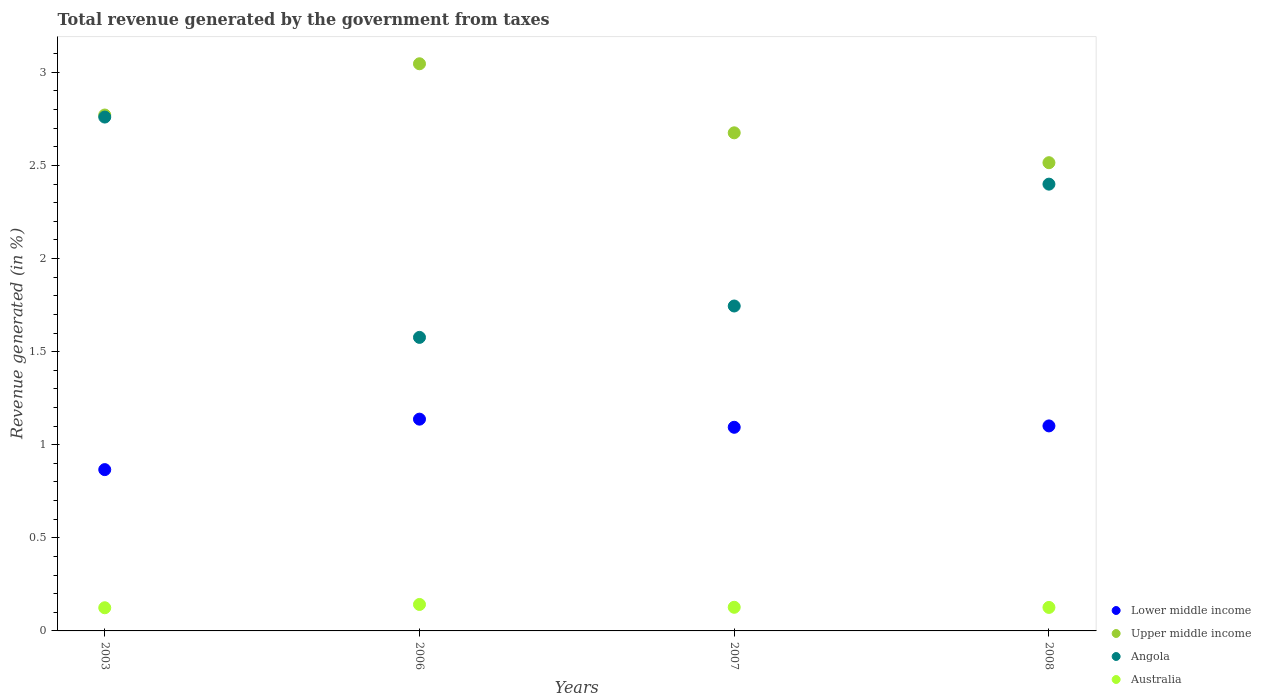How many different coloured dotlines are there?
Give a very brief answer. 4. What is the total revenue generated in Upper middle income in 2003?
Make the answer very short. 2.77. Across all years, what is the maximum total revenue generated in Lower middle income?
Your response must be concise. 1.14. Across all years, what is the minimum total revenue generated in Australia?
Offer a very short reply. 0.12. What is the total total revenue generated in Australia in the graph?
Ensure brevity in your answer.  0.52. What is the difference between the total revenue generated in Angola in 2003 and that in 2007?
Make the answer very short. 1.01. What is the difference between the total revenue generated in Upper middle income in 2008 and the total revenue generated in Australia in 2007?
Your answer should be very brief. 2.39. What is the average total revenue generated in Angola per year?
Your response must be concise. 2.12. In the year 2007, what is the difference between the total revenue generated in Angola and total revenue generated in Lower middle income?
Offer a terse response. 0.65. What is the ratio of the total revenue generated in Australia in 2003 to that in 2007?
Offer a terse response. 0.98. Is the total revenue generated in Lower middle income in 2007 less than that in 2008?
Your answer should be very brief. Yes. What is the difference between the highest and the second highest total revenue generated in Angola?
Ensure brevity in your answer.  0.36. What is the difference between the highest and the lowest total revenue generated in Lower middle income?
Offer a terse response. 0.27. In how many years, is the total revenue generated in Upper middle income greater than the average total revenue generated in Upper middle income taken over all years?
Offer a very short reply. 2. Is the sum of the total revenue generated in Australia in 2003 and 2006 greater than the maximum total revenue generated in Lower middle income across all years?
Ensure brevity in your answer.  No. Does the total revenue generated in Lower middle income monotonically increase over the years?
Provide a short and direct response. No. Is the total revenue generated in Angola strictly greater than the total revenue generated in Lower middle income over the years?
Ensure brevity in your answer.  Yes. Is the total revenue generated in Upper middle income strictly less than the total revenue generated in Lower middle income over the years?
Offer a very short reply. No. How many years are there in the graph?
Make the answer very short. 4. What is the difference between two consecutive major ticks on the Y-axis?
Provide a short and direct response. 0.5. Are the values on the major ticks of Y-axis written in scientific E-notation?
Your response must be concise. No. Does the graph contain grids?
Provide a short and direct response. No. Where does the legend appear in the graph?
Make the answer very short. Bottom right. What is the title of the graph?
Provide a succinct answer. Total revenue generated by the government from taxes. What is the label or title of the Y-axis?
Provide a short and direct response. Revenue generated (in %). What is the Revenue generated (in %) in Lower middle income in 2003?
Your response must be concise. 0.87. What is the Revenue generated (in %) in Upper middle income in 2003?
Offer a very short reply. 2.77. What is the Revenue generated (in %) of Angola in 2003?
Keep it short and to the point. 2.76. What is the Revenue generated (in %) of Australia in 2003?
Your answer should be compact. 0.12. What is the Revenue generated (in %) in Lower middle income in 2006?
Offer a very short reply. 1.14. What is the Revenue generated (in %) of Upper middle income in 2006?
Ensure brevity in your answer.  3.05. What is the Revenue generated (in %) of Angola in 2006?
Offer a very short reply. 1.58. What is the Revenue generated (in %) in Australia in 2006?
Provide a short and direct response. 0.14. What is the Revenue generated (in %) of Lower middle income in 2007?
Your response must be concise. 1.09. What is the Revenue generated (in %) of Upper middle income in 2007?
Offer a terse response. 2.68. What is the Revenue generated (in %) in Angola in 2007?
Keep it short and to the point. 1.75. What is the Revenue generated (in %) in Australia in 2007?
Your answer should be compact. 0.13. What is the Revenue generated (in %) in Lower middle income in 2008?
Offer a very short reply. 1.1. What is the Revenue generated (in %) in Upper middle income in 2008?
Your answer should be compact. 2.51. What is the Revenue generated (in %) in Angola in 2008?
Your answer should be very brief. 2.4. What is the Revenue generated (in %) of Australia in 2008?
Keep it short and to the point. 0.13. Across all years, what is the maximum Revenue generated (in %) in Lower middle income?
Your answer should be very brief. 1.14. Across all years, what is the maximum Revenue generated (in %) in Upper middle income?
Your answer should be very brief. 3.05. Across all years, what is the maximum Revenue generated (in %) in Angola?
Give a very brief answer. 2.76. Across all years, what is the maximum Revenue generated (in %) in Australia?
Offer a terse response. 0.14. Across all years, what is the minimum Revenue generated (in %) of Lower middle income?
Your answer should be very brief. 0.87. Across all years, what is the minimum Revenue generated (in %) in Upper middle income?
Ensure brevity in your answer.  2.51. Across all years, what is the minimum Revenue generated (in %) of Angola?
Make the answer very short. 1.58. Across all years, what is the minimum Revenue generated (in %) of Australia?
Your response must be concise. 0.12. What is the total Revenue generated (in %) of Lower middle income in the graph?
Provide a short and direct response. 4.2. What is the total Revenue generated (in %) of Upper middle income in the graph?
Offer a terse response. 11.01. What is the total Revenue generated (in %) in Angola in the graph?
Ensure brevity in your answer.  8.48. What is the total Revenue generated (in %) in Australia in the graph?
Offer a terse response. 0.52. What is the difference between the Revenue generated (in %) in Lower middle income in 2003 and that in 2006?
Offer a very short reply. -0.27. What is the difference between the Revenue generated (in %) of Upper middle income in 2003 and that in 2006?
Keep it short and to the point. -0.28. What is the difference between the Revenue generated (in %) in Angola in 2003 and that in 2006?
Offer a terse response. 1.18. What is the difference between the Revenue generated (in %) in Australia in 2003 and that in 2006?
Your answer should be very brief. -0.02. What is the difference between the Revenue generated (in %) of Lower middle income in 2003 and that in 2007?
Make the answer very short. -0.23. What is the difference between the Revenue generated (in %) in Upper middle income in 2003 and that in 2007?
Make the answer very short. 0.1. What is the difference between the Revenue generated (in %) of Angola in 2003 and that in 2007?
Offer a terse response. 1.01. What is the difference between the Revenue generated (in %) of Australia in 2003 and that in 2007?
Your answer should be very brief. -0. What is the difference between the Revenue generated (in %) of Lower middle income in 2003 and that in 2008?
Ensure brevity in your answer.  -0.23. What is the difference between the Revenue generated (in %) of Upper middle income in 2003 and that in 2008?
Make the answer very short. 0.26. What is the difference between the Revenue generated (in %) of Angola in 2003 and that in 2008?
Your answer should be very brief. 0.36. What is the difference between the Revenue generated (in %) in Australia in 2003 and that in 2008?
Offer a very short reply. -0. What is the difference between the Revenue generated (in %) of Lower middle income in 2006 and that in 2007?
Your answer should be very brief. 0.04. What is the difference between the Revenue generated (in %) in Upper middle income in 2006 and that in 2007?
Your answer should be very brief. 0.37. What is the difference between the Revenue generated (in %) of Angola in 2006 and that in 2007?
Your answer should be very brief. -0.17. What is the difference between the Revenue generated (in %) of Australia in 2006 and that in 2007?
Provide a short and direct response. 0.02. What is the difference between the Revenue generated (in %) in Lower middle income in 2006 and that in 2008?
Provide a short and direct response. 0.04. What is the difference between the Revenue generated (in %) in Upper middle income in 2006 and that in 2008?
Provide a short and direct response. 0.53. What is the difference between the Revenue generated (in %) of Angola in 2006 and that in 2008?
Provide a short and direct response. -0.82. What is the difference between the Revenue generated (in %) in Australia in 2006 and that in 2008?
Keep it short and to the point. 0.02. What is the difference between the Revenue generated (in %) of Lower middle income in 2007 and that in 2008?
Offer a very short reply. -0.01. What is the difference between the Revenue generated (in %) of Upper middle income in 2007 and that in 2008?
Your answer should be very brief. 0.16. What is the difference between the Revenue generated (in %) of Angola in 2007 and that in 2008?
Give a very brief answer. -0.65. What is the difference between the Revenue generated (in %) of Australia in 2007 and that in 2008?
Provide a short and direct response. 0. What is the difference between the Revenue generated (in %) of Lower middle income in 2003 and the Revenue generated (in %) of Upper middle income in 2006?
Ensure brevity in your answer.  -2.18. What is the difference between the Revenue generated (in %) in Lower middle income in 2003 and the Revenue generated (in %) in Angola in 2006?
Offer a very short reply. -0.71. What is the difference between the Revenue generated (in %) in Lower middle income in 2003 and the Revenue generated (in %) in Australia in 2006?
Your answer should be compact. 0.72. What is the difference between the Revenue generated (in %) of Upper middle income in 2003 and the Revenue generated (in %) of Angola in 2006?
Your answer should be very brief. 1.19. What is the difference between the Revenue generated (in %) of Upper middle income in 2003 and the Revenue generated (in %) of Australia in 2006?
Provide a succinct answer. 2.63. What is the difference between the Revenue generated (in %) in Angola in 2003 and the Revenue generated (in %) in Australia in 2006?
Offer a very short reply. 2.62. What is the difference between the Revenue generated (in %) in Lower middle income in 2003 and the Revenue generated (in %) in Upper middle income in 2007?
Offer a very short reply. -1.81. What is the difference between the Revenue generated (in %) of Lower middle income in 2003 and the Revenue generated (in %) of Angola in 2007?
Offer a very short reply. -0.88. What is the difference between the Revenue generated (in %) in Lower middle income in 2003 and the Revenue generated (in %) in Australia in 2007?
Your answer should be very brief. 0.74. What is the difference between the Revenue generated (in %) of Upper middle income in 2003 and the Revenue generated (in %) of Angola in 2007?
Your answer should be compact. 1.03. What is the difference between the Revenue generated (in %) in Upper middle income in 2003 and the Revenue generated (in %) in Australia in 2007?
Give a very brief answer. 2.64. What is the difference between the Revenue generated (in %) of Angola in 2003 and the Revenue generated (in %) of Australia in 2007?
Provide a succinct answer. 2.63. What is the difference between the Revenue generated (in %) of Lower middle income in 2003 and the Revenue generated (in %) of Upper middle income in 2008?
Keep it short and to the point. -1.65. What is the difference between the Revenue generated (in %) of Lower middle income in 2003 and the Revenue generated (in %) of Angola in 2008?
Offer a very short reply. -1.53. What is the difference between the Revenue generated (in %) of Lower middle income in 2003 and the Revenue generated (in %) of Australia in 2008?
Give a very brief answer. 0.74. What is the difference between the Revenue generated (in %) of Upper middle income in 2003 and the Revenue generated (in %) of Angola in 2008?
Provide a succinct answer. 0.37. What is the difference between the Revenue generated (in %) in Upper middle income in 2003 and the Revenue generated (in %) in Australia in 2008?
Provide a short and direct response. 2.64. What is the difference between the Revenue generated (in %) in Angola in 2003 and the Revenue generated (in %) in Australia in 2008?
Provide a short and direct response. 2.63. What is the difference between the Revenue generated (in %) of Lower middle income in 2006 and the Revenue generated (in %) of Upper middle income in 2007?
Provide a succinct answer. -1.54. What is the difference between the Revenue generated (in %) in Lower middle income in 2006 and the Revenue generated (in %) in Angola in 2007?
Provide a succinct answer. -0.61. What is the difference between the Revenue generated (in %) of Lower middle income in 2006 and the Revenue generated (in %) of Australia in 2007?
Offer a very short reply. 1.01. What is the difference between the Revenue generated (in %) of Upper middle income in 2006 and the Revenue generated (in %) of Angola in 2007?
Keep it short and to the point. 1.3. What is the difference between the Revenue generated (in %) in Upper middle income in 2006 and the Revenue generated (in %) in Australia in 2007?
Offer a very short reply. 2.92. What is the difference between the Revenue generated (in %) of Angola in 2006 and the Revenue generated (in %) of Australia in 2007?
Offer a very short reply. 1.45. What is the difference between the Revenue generated (in %) in Lower middle income in 2006 and the Revenue generated (in %) in Upper middle income in 2008?
Give a very brief answer. -1.38. What is the difference between the Revenue generated (in %) of Lower middle income in 2006 and the Revenue generated (in %) of Angola in 2008?
Offer a very short reply. -1.26. What is the difference between the Revenue generated (in %) of Lower middle income in 2006 and the Revenue generated (in %) of Australia in 2008?
Your response must be concise. 1.01. What is the difference between the Revenue generated (in %) in Upper middle income in 2006 and the Revenue generated (in %) in Angola in 2008?
Offer a very short reply. 0.65. What is the difference between the Revenue generated (in %) in Upper middle income in 2006 and the Revenue generated (in %) in Australia in 2008?
Your answer should be compact. 2.92. What is the difference between the Revenue generated (in %) in Angola in 2006 and the Revenue generated (in %) in Australia in 2008?
Ensure brevity in your answer.  1.45. What is the difference between the Revenue generated (in %) of Lower middle income in 2007 and the Revenue generated (in %) of Upper middle income in 2008?
Provide a short and direct response. -1.42. What is the difference between the Revenue generated (in %) in Lower middle income in 2007 and the Revenue generated (in %) in Angola in 2008?
Give a very brief answer. -1.31. What is the difference between the Revenue generated (in %) of Lower middle income in 2007 and the Revenue generated (in %) of Australia in 2008?
Offer a terse response. 0.97. What is the difference between the Revenue generated (in %) in Upper middle income in 2007 and the Revenue generated (in %) in Angola in 2008?
Give a very brief answer. 0.28. What is the difference between the Revenue generated (in %) of Upper middle income in 2007 and the Revenue generated (in %) of Australia in 2008?
Your response must be concise. 2.55. What is the difference between the Revenue generated (in %) in Angola in 2007 and the Revenue generated (in %) in Australia in 2008?
Provide a short and direct response. 1.62. What is the average Revenue generated (in %) of Lower middle income per year?
Offer a very short reply. 1.05. What is the average Revenue generated (in %) of Upper middle income per year?
Your response must be concise. 2.75. What is the average Revenue generated (in %) in Angola per year?
Your answer should be very brief. 2.12. What is the average Revenue generated (in %) of Australia per year?
Keep it short and to the point. 0.13. In the year 2003, what is the difference between the Revenue generated (in %) in Lower middle income and Revenue generated (in %) in Upper middle income?
Ensure brevity in your answer.  -1.9. In the year 2003, what is the difference between the Revenue generated (in %) in Lower middle income and Revenue generated (in %) in Angola?
Provide a short and direct response. -1.89. In the year 2003, what is the difference between the Revenue generated (in %) of Lower middle income and Revenue generated (in %) of Australia?
Provide a short and direct response. 0.74. In the year 2003, what is the difference between the Revenue generated (in %) in Upper middle income and Revenue generated (in %) in Angola?
Give a very brief answer. 0.01. In the year 2003, what is the difference between the Revenue generated (in %) of Upper middle income and Revenue generated (in %) of Australia?
Give a very brief answer. 2.65. In the year 2003, what is the difference between the Revenue generated (in %) in Angola and Revenue generated (in %) in Australia?
Offer a very short reply. 2.64. In the year 2006, what is the difference between the Revenue generated (in %) in Lower middle income and Revenue generated (in %) in Upper middle income?
Ensure brevity in your answer.  -1.91. In the year 2006, what is the difference between the Revenue generated (in %) of Lower middle income and Revenue generated (in %) of Angola?
Your answer should be very brief. -0.44. In the year 2006, what is the difference between the Revenue generated (in %) of Lower middle income and Revenue generated (in %) of Australia?
Make the answer very short. 1. In the year 2006, what is the difference between the Revenue generated (in %) of Upper middle income and Revenue generated (in %) of Angola?
Provide a succinct answer. 1.47. In the year 2006, what is the difference between the Revenue generated (in %) of Upper middle income and Revenue generated (in %) of Australia?
Your answer should be compact. 2.9. In the year 2006, what is the difference between the Revenue generated (in %) in Angola and Revenue generated (in %) in Australia?
Your answer should be compact. 1.43. In the year 2007, what is the difference between the Revenue generated (in %) of Lower middle income and Revenue generated (in %) of Upper middle income?
Your answer should be very brief. -1.58. In the year 2007, what is the difference between the Revenue generated (in %) in Lower middle income and Revenue generated (in %) in Angola?
Make the answer very short. -0.65. In the year 2007, what is the difference between the Revenue generated (in %) of Lower middle income and Revenue generated (in %) of Australia?
Keep it short and to the point. 0.97. In the year 2007, what is the difference between the Revenue generated (in %) of Upper middle income and Revenue generated (in %) of Angola?
Ensure brevity in your answer.  0.93. In the year 2007, what is the difference between the Revenue generated (in %) in Upper middle income and Revenue generated (in %) in Australia?
Make the answer very short. 2.55. In the year 2007, what is the difference between the Revenue generated (in %) of Angola and Revenue generated (in %) of Australia?
Offer a terse response. 1.62. In the year 2008, what is the difference between the Revenue generated (in %) of Lower middle income and Revenue generated (in %) of Upper middle income?
Make the answer very short. -1.41. In the year 2008, what is the difference between the Revenue generated (in %) in Lower middle income and Revenue generated (in %) in Angola?
Offer a terse response. -1.3. In the year 2008, what is the difference between the Revenue generated (in %) of Lower middle income and Revenue generated (in %) of Australia?
Your response must be concise. 0.97. In the year 2008, what is the difference between the Revenue generated (in %) of Upper middle income and Revenue generated (in %) of Angola?
Keep it short and to the point. 0.12. In the year 2008, what is the difference between the Revenue generated (in %) of Upper middle income and Revenue generated (in %) of Australia?
Provide a succinct answer. 2.39. In the year 2008, what is the difference between the Revenue generated (in %) of Angola and Revenue generated (in %) of Australia?
Offer a very short reply. 2.27. What is the ratio of the Revenue generated (in %) of Lower middle income in 2003 to that in 2006?
Provide a short and direct response. 0.76. What is the ratio of the Revenue generated (in %) of Upper middle income in 2003 to that in 2006?
Your response must be concise. 0.91. What is the ratio of the Revenue generated (in %) in Angola in 2003 to that in 2006?
Give a very brief answer. 1.75. What is the ratio of the Revenue generated (in %) in Australia in 2003 to that in 2006?
Offer a terse response. 0.88. What is the ratio of the Revenue generated (in %) in Lower middle income in 2003 to that in 2007?
Provide a succinct answer. 0.79. What is the ratio of the Revenue generated (in %) of Upper middle income in 2003 to that in 2007?
Your response must be concise. 1.04. What is the ratio of the Revenue generated (in %) of Angola in 2003 to that in 2007?
Offer a terse response. 1.58. What is the ratio of the Revenue generated (in %) of Australia in 2003 to that in 2007?
Provide a short and direct response. 0.98. What is the ratio of the Revenue generated (in %) in Lower middle income in 2003 to that in 2008?
Provide a succinct answer. 0.79. What is the ratio of the Revenue generated (in %) of Upper middle income in 2003 to that in 2008?
Provide a succinct answer. 1.1. What is the ratio of the Revenue generated (in %) of Angola in 2003 to that in 2008?
Your answer should be very brief. 1.15. What is the ratio of the Revenue generated (in %) of Australia in 2003 to that in 2008?
Provide a succinct answer. 0.99. What is the ratio of the Revenue generated (in %) in Lower middle income in 2006 to that in 2007?
Make the answer very short. 1.04. What is the ratio of the Revenue generated (in %) in Upper middle income in 2006 to that in 2007?
Give a very brief answer. 1.14. What is the ratio of the Revenue generated (in %) in Angola in 2006 to that in 2007?
Ensure brevity in your answer.  0.9. What is the ratio of the Revenue generated (in %) of Australia in 2006 to that in 2007?
Offer a terse response. 1.12. What is the ratio of the Revenue generated (in %) of Lower middle income in 2006 to that in 2008?
Provide a short and direct response. 1.03. What is the ratio of the Revenue generated (in %) of Upper middle income in 2006 to that in 2008?
Offer a terse response. 1.21. What is the ratio of the Revenue generated (in %) of Angola in 2006 to that in 2008?
Make the answer very short. 0.66. What is the ratio of the Revenue generated (in %) of Australia in 2006 to that in 2008?
Give a very brief answer. 1.13. What is the ratio of the Revenue generated (in %) in Upper middle income in 2007 to that in 2008?
Give a very brief answer. 1.06. What is the ratio of the Revenue generated (in %) in Angola in 2007 to that in 2008?
Ensure brevity in your answer.  0.73. What is the ratio of the Revenue generated (in %) in Australia in 2007 to that in 2008?
Make the answer very short. 1.01. What is the difference between the highest and the second highest Revenue generated (in %) in Lower middle income?
Your answer should be very brief. 0.04. What is the difference between the highest and the second highest Revenue generated (in %) in Upper middle income?
Your answer should be compact. 0.28. What is the difference between the highest and the second highest Revenue generated (in %) of Angola?
Your response must be concise. 0.36. What is the difference between the highest and the second highest Revenue generated (in %) of Australia?
Keep it short and to the point. 0.02. What is the difference between the highest and the lowest Revenue generated (in %) in Lower middle income?
Ensure brevity in your answer.  0.27. What is the difference between the highest and the lowest Revenue generated (in %) in Upper middle income?
Make the answer very short. 0.53. What is the difference between the highest and the lowest Revenue generated (in %) in Angola?
Offer a terse response. 1.18. What is the difference between the highest and the lowest Revenue generated (in %) of Australia?
Your answer should be very brief. 0.02. 